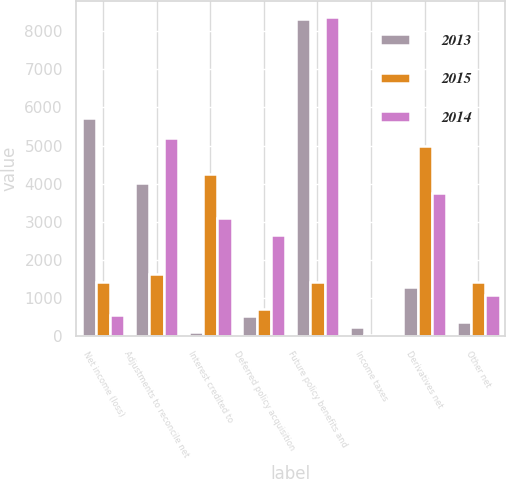Convert chart to OTSL. <chart><loc_0><loc_0><loc_500><loc_500><stacked_bar_chart><ecel><fcel>Net income (loss)<fcel>Adjustments to reconcile net<fcel>Interest credited to<fcel>Deferred policy acquisition<fcel>Future policy benefits and<fcel>Income taxes<fcel>Derivatives net<fcel>Other net<nl><fcel>2013<fcel>5712<fcel>4025<fcel>113<fcel>533<fcel>8311<fcel>256<fcel>1305<fcel>391<nl><fcel>2015<fcel>1438<fcel>1636<fcel>4263<fcel>721<fcel>1438<fcel>44<fcel>4989<fcel>1432<nl><fcel>2014<fcel>560<fcel>5206<fcel>3111<fcel>2661<fcel>8379<fcel>33<fcel>3747<fcel>1081<nl></chart> 